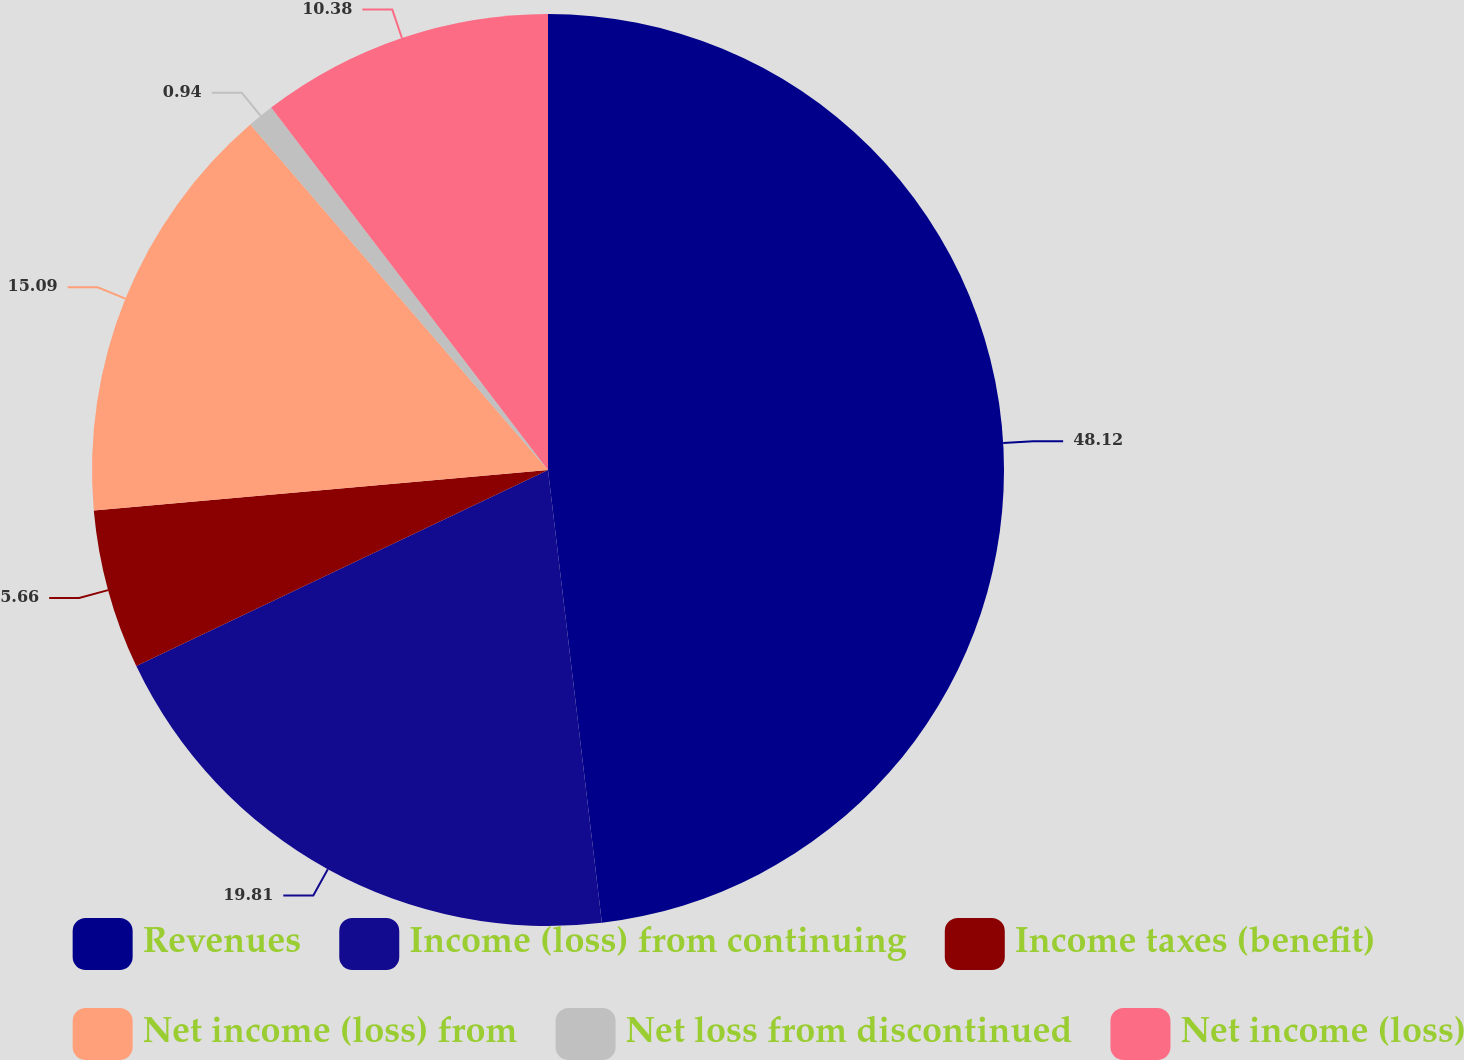Convert chart to OTSL. <chart><loc_0><loc_0><loc_500><loc_500><pie_chart><fcel>Revenues<fcel>Income (loss) from continuing<fcel>Income taxes (benefit)<fcel>Net income (loss) from<fcel>Net loss from discontinued<fcel>Net income (loss)<nl><fcel>48.11%<fcel>19.81%<fcel>5.66%<fcel>15.09%<fcel>0.94%<fcel>10.38%<nl></chart> 